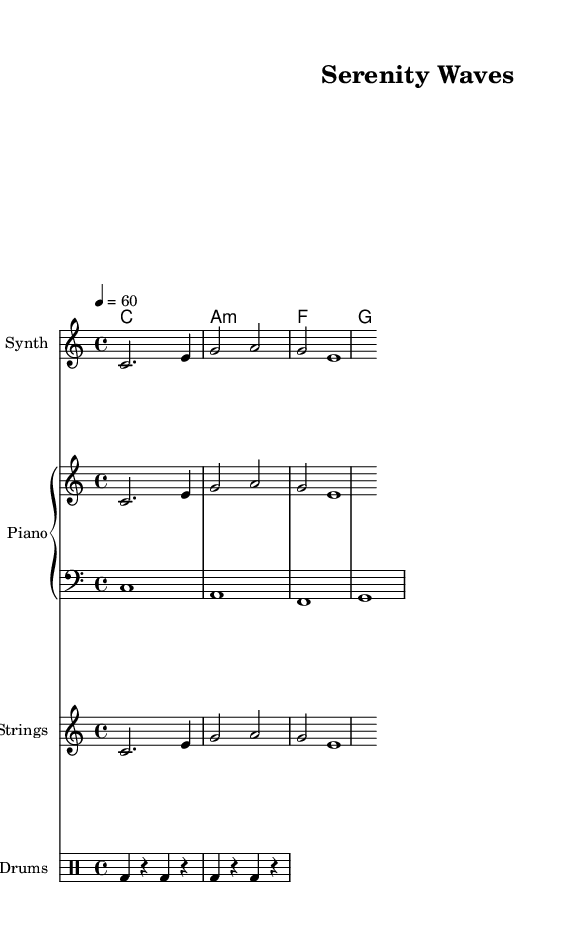What is the key signature of this music? The key signature is C major, which has no sharps or flats, as indicated at the beginning of the staff.
Answer: C major What is the time signature of this piece? The time signature is indicated as 4/4, meaning there are four beats per measure, with the quarter note getting one beat.
Answer: 4/4 What is the tempo marking for this piece? The tempo marking is indicated as 4 = 60, which suggests that each quarter note serves as a beat at a speed of 60 beats per minute.
Answer: 60 How many measures are in the melody? Counting the measures shown in the melody section, there are three measures present.
Answer: 3 What instruments are used in this composition? The instruments include Synth, Piano, Strings, and Drums, as labeled at the beginning of each staff.
Answer: Synth, Piano, Strings, Drums What is the chord that accompanies the first measure? The chord in the first measure is C major, which consists of the notes C, E, and G played simultaneously as indicated underneath the staff.
Answer: C How is the rhythm characterized in the drum part? The drum part alternates between bass drum hits and rests, creating a simple rhythmic pattern which contributes to the laid-back feel typical of ambient music.
Answer: Alternating bass drum and rests 